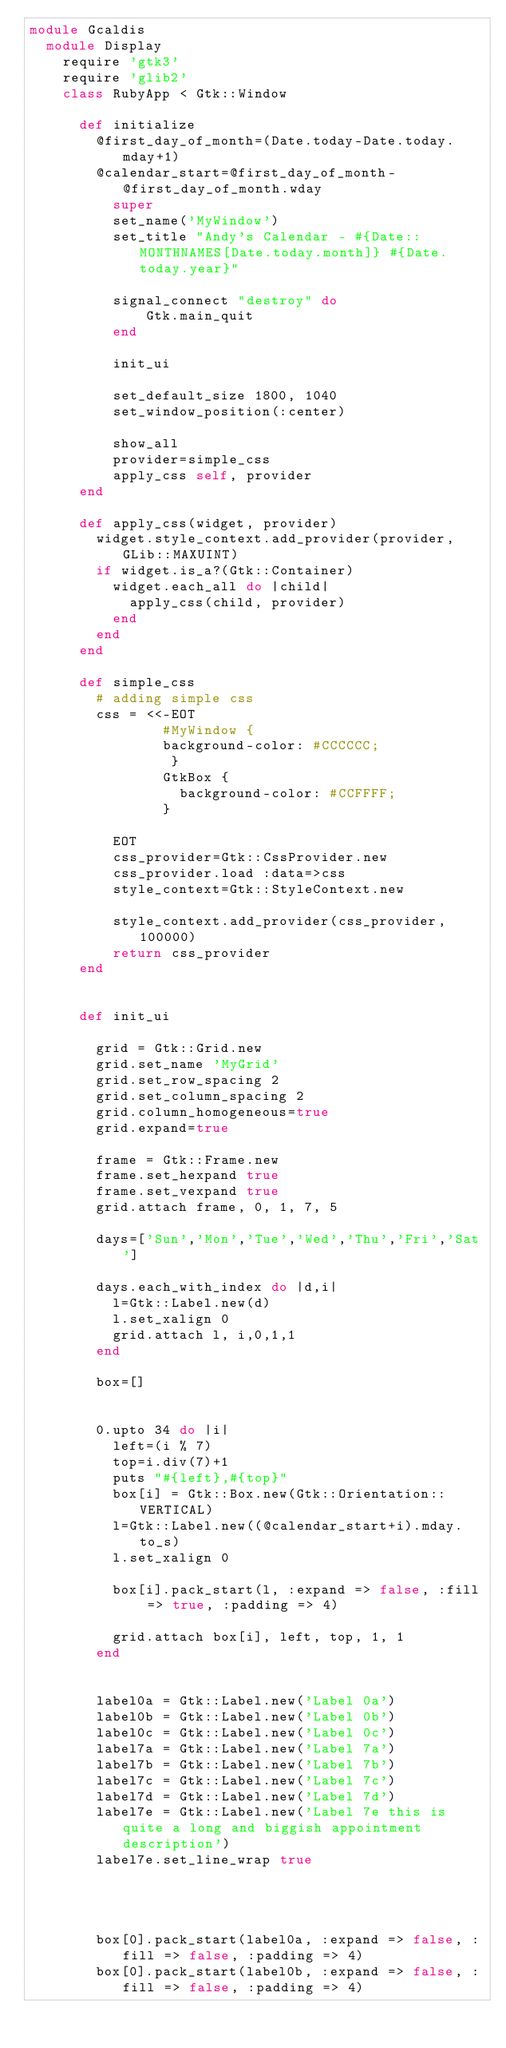<code> <loc_0><loc_0><loc_500><loc_500><_Ruby_>module Gcaldis
  module Display
    require 'gtk3'
    require 'glib2'
    class RubyApp < Gtk::Window
  
      def initialize
        @first_day_of_month=(Date.today-Date.today.mday+1)
        @calendar_start=@first_day_of_month-@first_day_of_month.wday
          super
          set_name('MyWindow')
          set_title "Andy's Calendar - #{Date::MONTHNAMES[Date.today.month]} #{Date.today.year}"
          
          signal_connect "destroy" do 
              Gtk.main_quit 
          end
          
          init_ui
          
          set_default_size 1800, 1040
          set_window_position(:center)
          
          show_all
          provider=simple_css
          apply_css self, provider
      end
      
      def apply_css(widget, provider)
        widget.style_context.add_provider(provider, GLib::MAXUINT)
        if widget.is_a?(Gtk::Container)
          widget.each_all do |child|
            apply_css(child, provider)
          end
        end
      end
      
      def simple_css
        # adding simple css
        css = <<-EOT
                #MyWindow {
                background-color: #CCCCCC;
                 }
                GtkBox {
                  background-color: #CCFFFF;
                }

          EOT
          css_provider=Gtk::CssProvider.new
          css_provider.load :data=>css
          style_context=Gtk::StyleContext.new

          style_context.add_provider(css_provider, 100000)
          return css_provider
      end
      
      
      def init_ui

        grid = Gtk::Grid.new 
        grid.set_name 'MyGrid'
        grid.set_row_spacing 2
        grid.set_column_spacing 2
        grid.column_homogeneous=true
        grid.expand=true
        
        frame = Gtk::Frame.new
        frame.set_hexpand true
        frame.set_vexpand true
        grid.attach frame, 0, 1, 7, 5
          
        days=['Sun','Mon','Tue','Wed','Thu','Fri','Sat']
        
        days.each_with_index do |d,i|
          l=Gtk::Label.new(d)
          l.set_xalign 0
          grid.attach l, i,0,1,1
        end
        
        box=[]

        
        0.upto 34 do |i|
          left=(i % 7)
          top=i.div(7)+1
          puts "#{left},#{top}"
          box[i] = Gtk::Box.new(Gtk::Orientation::VERTICAL)
          l=Gtk::Label.new((@calendar_start+i).mday.to_s)
          l.set_xalign 0
          
          box[i].pack_start(l, :expand => false, :fill => true, :padding => 4)
          
          grid.attach box[i], left, top, 1, 1
        end


        label0a = Gtk::Label.new('Label 0a')
        label0b = Gtk::Label.new('Label 0b')
        label0c = Gtk::Label.new('Label 0c')
        label7a = Gtk::Label.new('Label 7a')
        label7b = Gtk::Label.new('Label 7b')
        label7c = Gtk::Label.new('Label 7c')
        label7d = Gtk::Label.new('Label 7d')
        label7e = Gtk::Label.new('Label 7e this is quite a long and biggish appointment description')
        label7e.set_line_wrap true

        

        
        box[0].pack_start(label0a, :expand => false, :fill => false, :padding => 4)
        box[0].pack_start(label0b, :expand => false, :fill => false, :padding => 4)</code> 